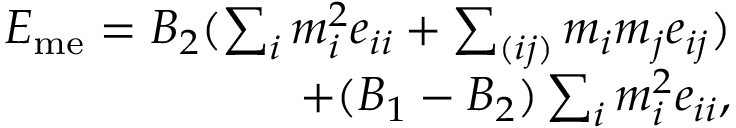<formula> <loc_0><loc_0><loc_500><loc_500>\begin{array} { r } { E _ { m e } = B _ { 2 } ( \sum _ { i } m _ { i } ^ { 2 } e _ { i i } + \sum _ { ( i j ) } m _ { i } m _ { j } e _ { i j } ) } \\ { + ( B _ { 1 } - B _ { 2 } ) \sum _ { i } m _ { i } ^ { 2 } e _ { i i } , } \end{array}</formula> 